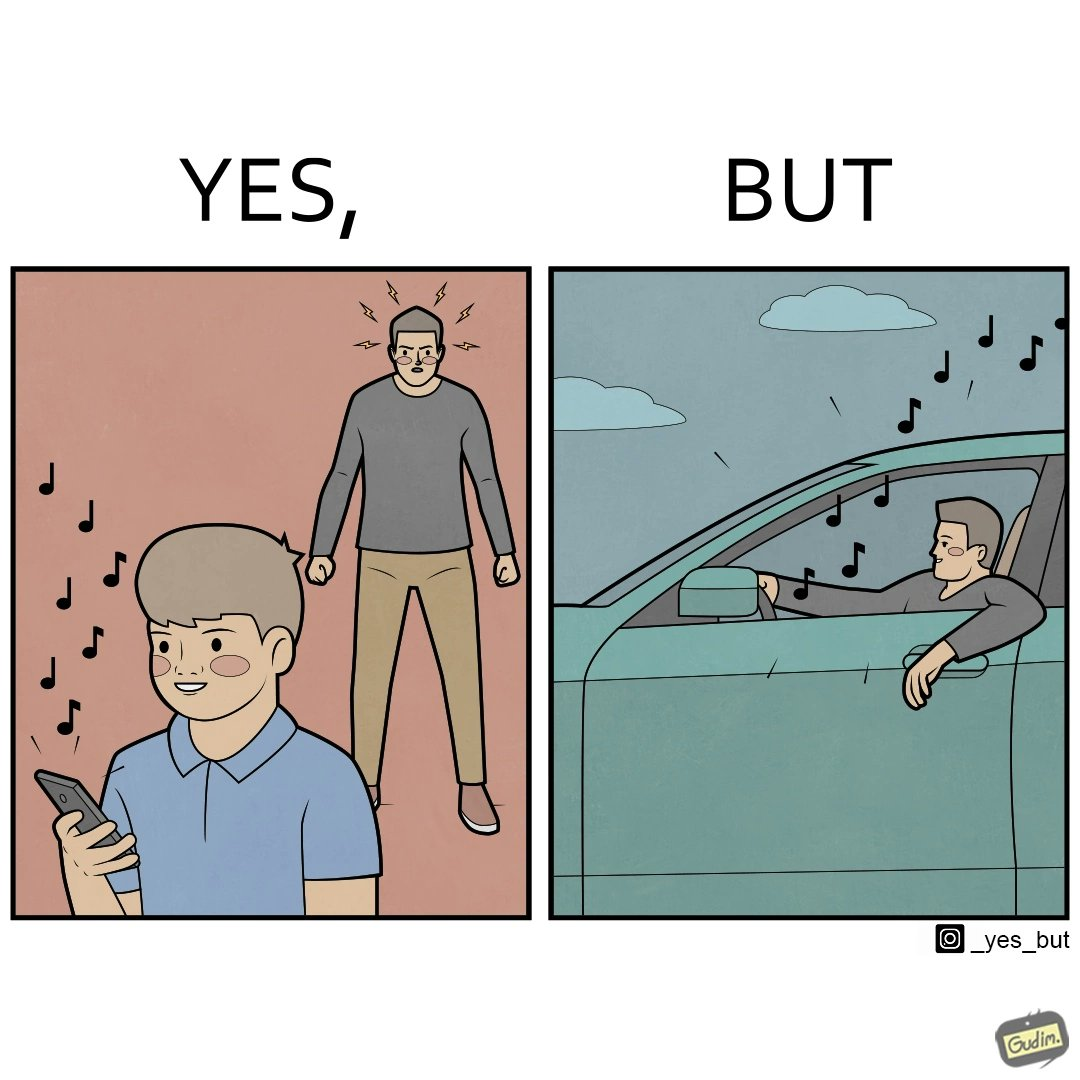Compare the left and right sides of this image. In the left part of the image: The image shows a boy playing music on his phone loudly. The image also shows another man annoyed by the loud music. In the right part of the image: The image shows a man driving a car with the windows of the car rolled down. He has one of his hands on the steering wheel and the other hand hanging out of the window of the driver side of the car. The man is playing loud music in his car with the sound coming out of the car. 